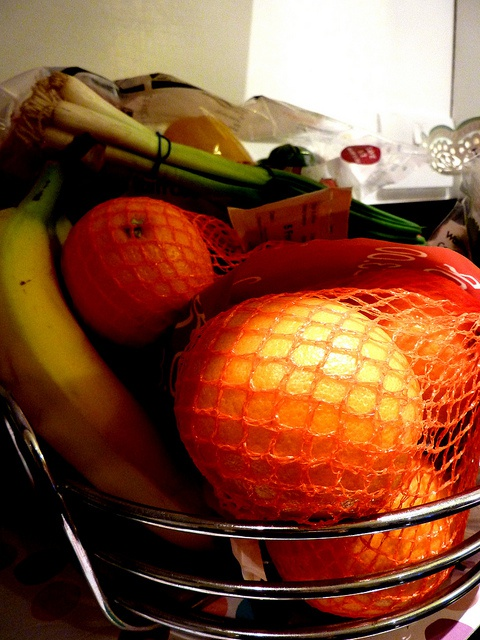Describe the objects in this image and their specific colors. I can see orange in gray, red, maroon, and orange tones, banana in gray, black, maroon, and olive tones, orange in gray, maroon, and red tones, and orange in gray, maroon, and red tones in this image. 